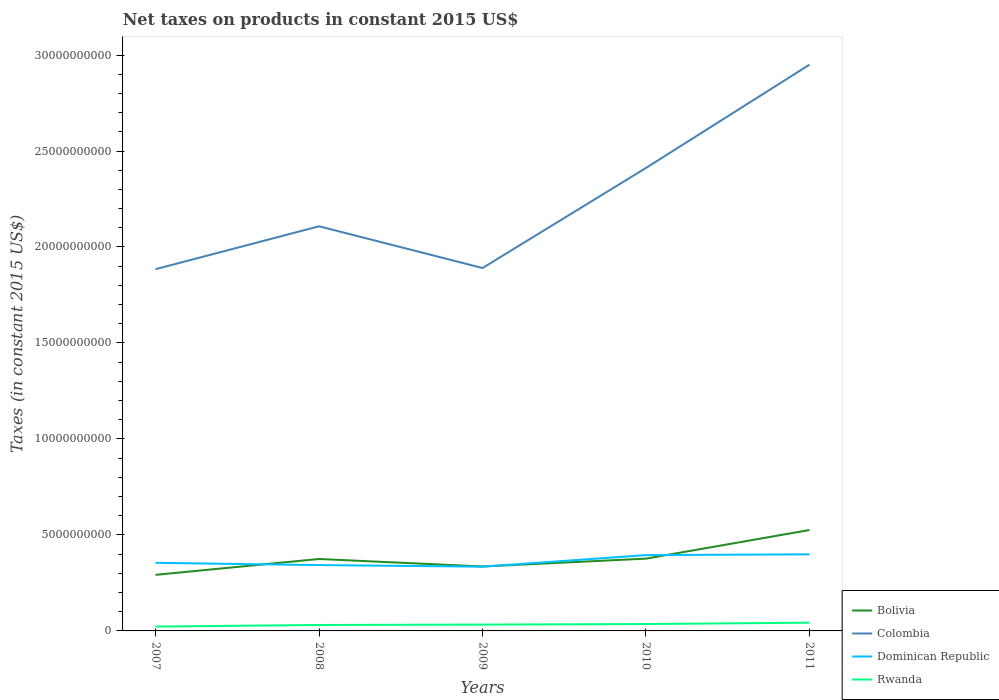How many different coloured lines are there?
Your answer should be compact. 4. Does the line corresponding to Rwanda intersect with the line corresponding to Colombia?
Offer a very short reply. No. Is the number of lines equal to the number of legend labels?
Give a very brief answer. Yes. Across all years, what is the maximum net taxes on products in Rwanda?
Offer a very short reply. 2.27e+08. In which year was the net taxes on products in Rwanda maximum?
Offer a terse response. 2007. What is the total net taxes on products in Dominican Republic in the graph?
Keep it short and to the point. -4.04e+07. What is the difference between the highest and the second highest net taxes on products in Dominican Republic?
Provide a short and direct response. 6.42e+08. How many lines are there?
Make the answer very short. 4. Does the graph contain any zero values?
Keep it short and to the point. No. Does the graph contain grids?
Give a very brief answer. No. How are the legend labels stacked?
Your response must be concise. Vertical. What is the title of the graph?
Your response must be concise. Net taxes on products in constant 2015 US$. What is the label or title of the X-axis?
Your answer should be very brief. Years. What is the label or title of the Y-axis?
Keep it short and to the point. Taxes (in constant 2015 US$). What is the Taxes (in constant 2015 US$) of Bolivia in 2007?
Ensure brevity in your answer.  2.92e+09. What is the Taxes (in constant 2015 US$) in Colombia in 2007?
Your answer should be compact. 1.88e+1. What is the Taxes (in constant 2015 US$) of Dominican Republic in 2007?
Your answer should be compact. 3.55e+09. What is the Taxes (in constant 2015 US$) of Rwanda in 2007?
Your response must be concise. 2.27e+08. What is the Taxes (in constant 2015 US$) of Bolivia in 2008?
Offer a terse response. 3.75e+09. What is the Taxes (in constant 2015 US$) in Colombia in 2008?
Offer a very short reply. 2.11e+1. What is the Taxes (in constant 2015 US$) of Dominican Republic in 2008?
Your response must be concise. 3.43e+09. What is the Taxes (in constant 2015 US$) in Rwanda in 2008?
Your answer should be very brief. 3.09e+08. What is the Taxes (in constant 2015 US$) of Bolivia in 2009?
Your answer should be compact. 3.36e+09. What is the Taxes (in constant 2015 US$) of Colombia in 2009?
Offer a very short reply. 1.89e+1. What is the Taxes (in constant 2015 US$) in Dominican Republic in 2009?
Your answer should be compact. 3.35e+09. What is the Taxes (in constant 2015 US$) of Rwanda in 2009?
Offer a terse response. 3.31e+08. What is the Taxes (in constant 2015 US$) in Bolivia in 2010?
Your answer should be compact. 3.77e+09. What is the Taxes (in constant 2015 US$) in Colombia in 2010?
Offer a terse response. 2.41e+1. What is the Taxes (in constant 2015 US$) of Dominican Republic in 2010?
Offer a terse response. 3.95e+09. What is the Taxes (in constant 2015 US$) of Rwanda in 2010?
Your answer should be very brief. 3.58e+08. What is the Taxes (in constant 2015 US$) of Bolivia in 2011?
Provide a short and direct response. 5.26e+09. What is the Taxes (in constant 2015 US$) of Colombia in 2011?
Offer a very short reply. 2.95e+1. What is the Taxes (in constant 2015 US$) of Dominican Republic in 2011?
Make the answer very short. 3.99e+09. What is the Taxes (in constant 2015 US$) of Rwanda in 2011?
Give a very brief answer. 4.30e+08. Across all years, what is the maximum Taxes (in constant 2015 US$) in Bolivia?
Offer a terse response. 5.26e+09. Across all years, what is the maximum Taxes (in constant 2015 US$) of Colombia?
Make the answer very short. 2.95e+1. Across all years, what is the maximum Taxes (in constant 2015 US$) of Dominican Republic?
Keep it short and to the point. 3.99e+09. Across all years, what is the maximum Taxes (in constant 2015 US$) in Rwanda?
Provide a short and direct response. 4.30e+08. Across all years, what is the minimum Taxes (in constant 2015 US$) of Bolivia?
Your answer should be compact. 2.92e+09. Across all years, what is the minimum Taxes (in constant 2015 US$) of Colombia?
Your answer should be compact. 1.88e+1. Across all years, what is the minimum Taxes (in constant 2015 US$) of Dominican Republic?
Offer a very short reply. 3.35e+09. Across all years, what is the minimum Taxes (in constant 2015 US$) in Rwanda?
Offer a terse response. 2.27e+08. What is the total Taxes (in constant 2015 US$) in Bolivia in the graph?
Ensure brevity in your answer.  1.90e+1. What is the total Taxes (in constant 2015 US$) of Colombia in the graph?
Make the answer very short. 1.12e+11. What is the total Taxes (in constant 2015 US$) of Dominican Republic in the graph?
Your response must be concise. 1.83e+1. What is the total Taxes (in constant 2015 US$) of Rwanda in the graph?
Ensure brevity in your answer.  1.65e+09. What is the difference between the Taxes (in constant 2015 US$) of Bolivia in 2007 and that in 2008?
Ensure brevity in your answer.  -8.27e+08. What is the difference between the Taxes (in constant 2015 US$) in Colombia in 2007 and that in 2008?
Give a very brief answer. -2.23e+09. What is the difference between the Taxes (in constant 2015 US$) of Dominican Republic in 2007 and that in 2008?
Offer a terse response. 1.17e+08. What is the difference between the Taxes (in constant 2015 US$) of Rwanda in 2007 and that in 2008?
Offer a terse response. -8.23e+07. What is the difference between the Taxes (in constant 2015 US$) of Bolivia in 2007 and that in 2009?
Keep it short and to the point. -4.36e+08. What is the difference between the Taxes (in constant 2015 US$) in Colombia in 2007 and that in 2009?
Provide a succinct answer. -6.03e+07. What is the difference between the Taxes (in constant 2015 US$) of Dominican Republic in 2007 and that in 2009?
Make the answer very short. 1.99e+08. What is the difference between the Taxes (in constant 2015 US$) in Rwanda in 2007 and that in 2009?
Offer a very short reply. -1.04e+08. What is the difference between the Taxes (in constant 2015 US$) of Bolivia in 2007 and that in 2010?
Your answer should be very brief. -8.45e+08. What is the difference between the Taxes (in constant 2015 US$) of Colombia in 2007 and that in 2010?
Provide a succinct answer. -5.27e+09. What is the difference between the Taxes (in constant 2015 US$) of Dominican Republic in 2007 and that in 2010?
Make the answer very short. -4.02e+08. What is the difference between the Taxes (in constant 2015 US$) in Rwanda in 2007 and that in 2010?
Offer a very short reply. -1.32e+08. What is the difference between the Taxes (in constant 2015 US$) in Bolivia in 2007 and that in 2011?
Your answer should be compact. -2.34e+09. What is the difference between the Taxes (in constant 2015 US$) of Colombia in 2007 and that in 2011?
Offer a very short reply. -1.07e+1. What is the difference between the Taxes (in constant 2015 US$) in Dominican Republic in 2007 and that in 2011?
Make the answer very short. -4.43e+08. What is the difference between the Taxes (in constant 2015 US$) in Rwanda in 2007 and that in 2011?
Offer a terse response. -2.03e+08. What is the difference between the Taxes (in constant 2015 US$) in Bolivia in 2008 and that in 2009?
Your answer should be very brief. 3.91e+08. What is the difference between the Taxes (in constant 2015 US$) of Colombia in 2008 and that in 2009?
Provide a short and direct response. 2.17e+09. What is the difference between the Taxes (in constant 2015 US$) of Dominican Republic in 2008 and that in 2009?
Ensure brevity in your answer.  8.22e+07. What is the difference between the Taxes (in constant 2015 US$) of Rwanda in 2008 and that in 2009?
Ensure brevity in your answer.  -2.18e+07. What is the difference between the Taxes (in constant 2015 US$) of Bolivia in 2008 and that in 2010?
Offer a terse response. -1.85e+07. What is the difference between the Taxes (in constant 2015 US$) of Colombia in 2008 and that in 2010?
Keep it short and to the point. -3.04e+09. What is the difference between the Taxes (in constant 2015 US$) of Dominican Republic in 2008 and that in 2010?
Your answer should be compact. -5.19e+08. What is the difference between the Taxes (in constant 2015 US$) in Rwanda in 2008 and that in 2010?
Your answer should be compact. -4.94e+07. What is the difference between the Taxes (in constant 2015 US$) of Bolivia in 2008 and that in 2011?
Your response must be concise. -1.51e+09. What is the difference between the Taxes (in constant 2015 US$) of Colombia in 2008 and that in 2011?
Provide a short and direct response. -8.42e+09. What is the difference between the Taxes (in constant 2015 US$) in Dominican Republic in 2008 and that in 2011?
Provide a succinct answer. -5.60e+08. What is the difference between the Taxes (in constant 2015 US$) of Rwanda in 2008 and that in 2011?
Your response must be concise. -1.21e+08. What is the difference between the Taxes (in constant 2015 US$) of Bolivia in 2009 and that in 2010?
Ensure brevity in your answer.  -4.09e+08. What is the difference between the Taxes (in constant 2015 US$) in Colombia in 2009 and that in 2010?
Provide a succinct answer. -5.21e+09. What is the difference between the Taxes (in constant 2015 US$) of Dominican Republic in 2009 and that in 2010?
Make the answer very short. -6.01e+08. What is the difference between the Taxes (in constant 2015 US$) of Rwanda in 2009 and that in 2010?
Offer a terse response. -2.76e+07. What is the difference between the Taxes (in constant 2015 US$) in Bolivia in 2009 and that in 2011?
Your answer should be very brief. -1.90e+09. What is the difference between the Taxes (in constant 2015 US$) in Colombia in 2009 and that in 2011?
Offer a very short reply. -1.06e+1. What is the difference between the Taxes (in constant 2015 US$) of Dominican Republic in 2009 and that in 2011?
Offer a very short reply. -6.42e+08. What is the difference between the Taxes (in constant 2015 US$) of Rwanda in 2009 and that in 2011?
Keep it short and to the point. -9.90e+07. What is the difference between the Taxes (in constant 2015 US$) in Bolivia in 2010 and that in 2011?
Make the answer very short. -1.49e+09. What is the difference between the Taxes (in constant 2015 US$) in Colombia in 2010 and that in 2011?
Your answer should be very brief. -5.38e+09. What is the difference between the Taxes (in constant 2015 US$) of Dominican Republic in 2010 and that in 2011?
Your answer should be very brief. -4.04e+07. What is the difference between the Taxes (in constant 2015 US$) in Rwanda in 2010 and that in 2011?
Offer a very short reply. -7.14e+07. What is the difference between the Taxes (in constant 2015 US$) in Bolivia in 2007 and the Taxes (in constant 2015 US$) in Colombia in 2008?
Your response must be concise. -1.82e+1. What is the difference between the Taxes (in constant 2015 US$) of Bolivia in 2007 and the Taxes (in constant 2015 US$) of Dominican Republic in 2008?
Provide a succinct answer. -5.10e+08. What is the difference between the Taxes (in constant 2015 US$) of Bolivia in 2007 and the Taxes (in constant 2015 US$) of Rwanda in 2008?
Provide a succinct answer. 2.61e+09. What is the difference between the Taxes (in constant 2015 US$) of Colombia in 2007 and the Taxes (in constant 2015 US$) of Dominican Republic in 2008?
Keep it short and to the point. 1.54e+1. What is the difference between the Taxes (in constant 2015 US$) of Colombia in 2007 and the Taxes (in constant 2015 US$) of Rwanda in 2008?
Your response must be concise. 1.85e+1. What is the difference between the Taxes (in constant 2015 US$) of Dominican Republic in 2007 and the Taxes (in constant 2015 US$) of Rwanda in 2008?
Keep it short and to the point. 3.24e+09. What is the difference between the Taxes (in constant 2015 US$) of Bolivia in 2007 and the Taxes (in constant 2015 US$) of Colombia in 2009?
Give a very brief answer. -1.60e+1. What is the difference between the Taxes (in constant 2015 US$) of Bolivia in 2007 and the Taxes (in constant 2015 US$) of Dominican Republic in 2009?
Your answer should be very brief. -4.28e+08. What is the difference between the Taxes (in constant 2015 US$) in Bolivia in 2007 and the Taxes (in constant 2015 US$) in Rwanda in 2009?
Provide a short and direct response. 2.59e+09. What is the difference between the Taxes (in constant 2015 US$) of Colombia in 2007 and the Taxes (in constant 2015 US$) of Dominican Republic in 2009?
Your answer should be very brief. 1.55e+1. What is the difference between the Taxes (in constant 2015 US$) of Colombia in 2007 and the Taxes (in constant 2015 US$) of Rwanda in 2009?
Offer a very short reply. 1.85e+1. What is the difference between the Taxes (in constant 2015 US$) in Dominican Republic in 2007 and the Taxes (in constant 2015 US$) in Rwanda in 2009?
Give a very brief answer. 3.22e+09. What is the difference between the Taxes (in constant 2015 US$) in Bolivia in 2007 and the Taxes (in constant 2015 US$) in Colombia in 2010?
Ensure brevity in your answer.  -2.12e+1. What is the difference between the Taxes (in constant 2015 US$) of Bolivia in 2007 and the Taxes (in constant 2015 US$) of Dominican Republic in 2010?
Your answer should be very brief. -1.03e+09. What is the difference between the Taxes (in constant 2015 US$) of Bolivia in 2007 and the Taxes (in constant 2015 US$) of Rwanda in 2010?
Your response must be concise. 2.56e+09. What is the difference between the Taxes (in constant 2015 US$) of Colombia in 2007 and the Taxes (in constant 2015 US$) of Dominican Republic in 2010?
Give a very brief answer. 1.49e+1. What is the difference between the Taxes (in constant 2015 US$) in Colombia in 2007 and the Taxes (in constant 2015 US$) in Rwanda in 2010?
Keep it short and to the point. 1.85e+1. What is the difference between the Taxes (in constant 2015 US$) in Dominican Republic in 2007 and the Taxes (in constant 2015 US$) in Rwanda in 2010?
Provide a short and direct response. 3.19e+09. What is the difference between the Taxes (in constant 2015 US$) of Bolivia in 2007 and the Taxes (in constant 2015 US$) of Colombia in 2011?
Keep it short and to the point. -2.66e+1. What is the difference between the Taxes (in constant 2015 US$) in Bolivia in 2007 and the Taxes (in constant 2015 US$) in Dominican Republic in 2011?
Keep it short and to the point. -1.07e+09. What is the difference between the Taxes (in constant 2015 US$) in Bolivia in 2007 and the Taxes (in constant 2015 US$) in Rwanda in 2011?
Provide a short and direct response. 2.49e+09. What is the difference between the Taxes (in constant 2015 US$) in Colombia in 2007 and the Taxes (in constant 2015 US$) in Dominican Republic in 2011?
Keep it short and to the point. 1.49e+1. What is the difference between the Taxes (in constant 2015 US$) in Colombia in 2007 and the Taxes (in constant 2015 US$) in Rwanda in 2011?
Keep it short and to the point. 1.84e+1. What is the difference between the Taxes (in constant 2015 US$) in Dominican Republic in 2007 and the Taxes (in constant 2015 US$) in Rwanda in 2011?
Provide a succinct answer. 3.12e+09. What is the difference between the Taxes (in constant 2015 US$) of Bolivia in 2008 and the Taxes (in constant 2015 US$) of Colombia in 2009?
Your answer should be very brief. -1.52e+1. What is the difference between the Taxes (in constant 2015 US$) in Bolivia in 2008 and the Taxes (in constant 2015 US$) in Dominican Republic in 2009?
Provide a succinct answer. 3.99e+08. What is the difference between the Taxes (in constant 2015 US$) of Bolivia in 2008 and the Taxes (in constant 2015 US$) of Rwanda in 2009?
Your answer should be very brief. 3.42e+09. What is the difference between the Taxes (in constant 2015 US$) in Colombia in 2008 and the Taxes (in constant 2015 US$) in Dominican Republic in 2009?
Offer a terse response. 1.77e+1. What is the difference between the Taxes (in constant 2015 US$) in Colombia in 2008 and the Taxes (in constant 2015 US$) in Rwanda in 2009?
Provide a short and direct response. 2.07e+1. What is the difference between the Taxes (in constant 2015 US$) of Dominican Republic in 2008 and the Taxes (in constant 2015 US$) of Rwanda in 2009?
Offer a very short reply. 3.10e+09. What is the difference between the Taxes (in constant 2015 US$) of Bolivia in 2008 and the Taxes (in constant 2015 US$) of Colombia in 2010?
Provide a succinct answer. -2.04e+1. What is the difference between the Taxes (in constant 2015 US$) in Bolivia in 2008 and the Taxes (in constant 2015 US$) in Dominican Republic in 2010?
Provide a succinct answer. -2.02e+08. What is the difference between the Taxes (in constant 2015 US$) in Bolivia in 2008 and the Taxes (in constant 2015 US$) in Rwanda in 2010?
Offer a very short reply. 3.39e+09. What is the difference between the Taxes (in constant 2015 US$) in Colombia in 2008 and the Taxes (in constant 2015 US$) in Dominican Republic in 2010?
Provide a short and direct response. 1.71e+1. What is the difference between the Taxes (in constant 2015 US$) of Colombia in 2008 and the Taxes (in constant 2015 US$) of Rwanda in 2010?
Your answer should be very brief. 2.07e+1. What is the difference between the Taxes (in constant 2015 US$) in Dominican Republic in 2008 and the Taxes (in constant 2015 US$) in Rwanda in 2010?
Offer a very short reply. 3.07e+09. What is the difference between the Taxes (in constant 2015 US$) in Bolivia in 2008 and the Taxes (in constant 2015 US$) in Colombia in 2011?
Your answer should be very brief. -2.57e+1. What is the difference between the Taxes (in constant 2015 US$) of Bolivia in 2008 and the Taxes (in constant 2015 US$) of Dominican Republic in 2011?
Your answer should be very brief. -2.42e+08. What is the difference between the Taxes (in constant 2015 US$) of Bolivia in 2008 and the Taxes (in constant 2015 US$) of Rwanda in 2011?
Offer a very short reply. 3.32e+09. What is the difference between the Taxes (in constant 2015 US$) in Colombia in 2008 and the Taxes (in constant 2015 US$) in Dominican Republic in 2011?
Offer a very short reply. 1.71e+1. What is the difference between the Taxes (in constant 2015 US$) of Colombia in 2008 and the Taxes (in constant 2015 US$) of Rwanda in 2011?
Make the answer very short. 2.06e+1. What is the difference between the Taxes (in constant 2015 US$) of Dominican Republic in 2008 and the Taxes (in constant 2015 US$) of Rwanda in 2011?
Your answer should be very brief. 3.00e+09. What is the difference between the Taxes (in constant 2015 US$) in Bolivia in 2009 and the Taxes (in constant 2015 US$) in Colombia in 2010?
Offer a very short reply. -2.08e+1. What is the difference between the Taxes (in constant 2015 US$) of Bolivia in 2009 and the Taxes (in constant 2015 US$) of Dominican Republic in 2010?
Keep it short and to the point. -5.93e+08. What is the difference between the Taxes (in constant 2015 US$) in Bolivia in 2009 and the Taxes (in constant 2015 US$) in Rwanda in 2010?
Your answer should be compact. 3.00e+09. What is the difference between the Taxes (in constant 2015 US$) in Colombia in 2009 and the Taxes (in constant 2015 US$) in Dominican Republic in 2010?
Make the answer very short. 1.50e+1. What is the difference between the Taxes (in constant 2015 US$) in Colombia in 2009 and the Taxes (in constant 2015 US$) in Rwanda in 2010?
Provide a short and direct response. 1.85e+1. What is the difference between the Taxes (in constant 2015 US$) in Dominican Republic in 2009 and the Taxes (in constant 2015 US$) in Rwanda in 2010?
Keep it short and to the point. 2.99e+09. What is the difference between the Taxes (in constant 2015 US$) of Bolivia in 2009 and the Taxes (in constant 2015 US$) of Colombia in 2011?
Ensure brevity in your answer.  -2.61e+1. What is the difference between the Taxes (in constant 2015 US$) in Bolivia in 2009 and the Taxes (in constant 2015 US$) in Dominican Republic in 2011?
Your response must be concise. -6.33e+08. What is the difference between the Taxes (in constant 2015 US$) of Bolivia in 2009 and the Taxes (in constant 2015 US$) of Rwanda in 2011?
Keep it short and to the point. 2.93e+09. What is the difference between the Taxes (in constant 2015 US$) of Colombia in 2009 and the Taxes (in constant 2015 US$) of Dominican Republic in 2011?
Your answer should be very brief. 1.49e+1. What is the difference between the Taxes (in constant 2015 US$) of Colombia in 2009 and the Taxes (in constant 2015 US$) of Rwanda in 2011?
Provide a short and direct response. 1.85e+1. What is the difference between the Taxes (in constant 2015 US$) of Dominican Republic in 2009 and the Taxes (in constant 2015 US$) of Rwanda in 2011?
Your answer should be compact. 2.92e+09. What is the difference between the Taxes (in constant 2015 US$) of Bolivia in 2010 and the Taxes (in constant 2015 US$) of Colombia in 2011?
Your answer should be compact. -2.57e+1. What is the difference between the Taxes (in constant 2015 US$) in Bolivia in 2010 and the Taxes (in constant 2015 US$) in Dominican Republic in 2011?
Give a very brief answer. -2.24e+08. What is the difference between the Taxes (in constant 2015 US$) of Bolivia in 2010 and the Taxes (in constant 2015 US$) of Rwanda in 2011?
Keep it short and to the point. 3.34e+09. What is the difference between the Taxes (in constant 2015 US$) of Colombia in 2010 and the Taxes (in constant 2015 US$) of Dominican Republic in 2011?
Offer a very short reply. 2.01e+1. What is the difference between the Taxes (in constant 2015 US$) of Colombia in 2010 and the Taxes (in constant 2015 US$) of Rwanda in 2011?
Your response must be concise. 2.37e+1. What is the difference between the Taxes (in constant 2015 US$) in Dominican Republic in 2010 and the Taxes (in constant 2015 US$) in Rwanda in 2011?
Keep it short and to the point. 3.52e+09. What is the average Taxes (in constant 2015 US$) of Bolivia per year?
Your answer should be very brief. 3.81e+09. What is the average Taxes (in constant 2015 US$) in Colombia per year?
Offer a very short reply. 2.25e+1. What is the average Taxes (in constant 2015 US$) in Dominican Republic per year?
Your answer should be very brief. 3.65e+09. What is the average Taxes (in constant 2015 US$) of Rwanda per year?
Keep it short and to the point. 3.31e+08. In the year 2007, what is the difference between the Taxes (in constant 2015 US$) in Bolivia and Taxes (in constant 2015 US$) in Colombia?
Give a very brief answer. -1.59e+1. In the year 2007, what is the difference between the Taxes (in constant 2015 US$) of Bolivia and Taxes (in constant 2015 US$) of Dominican Republic?
Provide a succinct answer. -6.27e+08. In the year 2007, what is the difference between the Taxes (in constant 2015 US$) in Bolivia and Taxes (in constant 2015 US$) in Rwanda?
Provide a short and direct response. 2.69e+09. In the year 2007, what is the difference between the Taxes (in constant 2015 US$) of Colombia and Taxes (in constant 2015 US$) of Dominican Republic?
Your response must be concise. 1.53e+1. In the year 2007, what is the difference between the Taxes (in constant 2015 US$) in Colombia and Taxes (in constant 2015 US$) in Rwanda?
Your answer should be compact. 1.86e+1. In the year 2007, what is the difference between the Taxes (in constant 2015 US$) of Dominican Republic and Taxes (in constant 2015 US$) of Rwanda?
Offer a terse response. 3.32e+09. In the year 2008, what is the difference between the Taxes (in constant 2015 US$) in Bolivia and Taxes (in constant 2015 US$) in Colombia?
Provide a short and direct response. -1.73e+1. In the year 2008, what is the difference between the Taxes (in constant 2015 US$) of Bolivia and Taxes (in constant 2015 US$) of Dominican Republic?
Keep it short and to the point. 3.17e+08. In the year 2008, what is the difference between the Taxes (in constant 2015 US$) in Bolivia and Taxes (in constant 2015 US$) in Rwanda?
Offer a very short reply. 3.44e+09. In the year 2008, what is the difference between the Taxes (in constant 2015 US$) of Colombia and Taxes (in constant 2015 US$) of Dominican Republic?
Your answer should be very brief. 1.76e+1. In the year 2008, what is the difference between the Taxes (in constant 2015 US$) in Colombia and Taxes (in constant 2015 US$) in Rwanda?
Your answer should be compact. 2.08e+1. In the year 2008, what is the difference between the Taxes (in constant 2015 US$) in Dominican Republic and Taxes (in constant 2015 US$) in Rwanda?
Provide a succinct answer. 3.12e+09. In the year 2009, what is the difference between the Taxes (in constant 2015 US$) in Bolivia and Taxes (in constant 2015 US$) in Colombia?
Offer a terse response. -1.55e+1. In the year 2009, what is the difference between the Taxes (in constant 2015 US$) of Bolivia and Taxes (in constant 2015 US$) of Dominican Republic?
Your response must be concise. 8.67e+06. In the year 2009, what is the difference between the Taxes (in constant 2015 US$) of Bolivia and Taxes (in constant 2015 US$) of Rwanda?
Your response must be concise. 3.03e+09. In the year 2009, what is the difference between the Taxes (in constant 2015 US$) in Colombia and Taxes (in constant 2015 US$) in Dominican Republic?
Give a very brief answer. 1.56e+1. In the year 2009, what is the difference between the Taxes (in constant 2015 US$) in Colombia and Taxes (in constant 2015 US$) in Rwanda?
Provide a short and direct response. 1.86e+1. In the year 2009, what is the difference between the Taxes (in constant 2015 US$) of Dominican Republic and Taxes (in constant 2015 US$) of Rwanda?
Keep it short and to the point. 3.02e+09. In the year 2010, what is the difference between the Taxes (in constant 2015 US$) in Bolivia and Taxes (in constant 2015 US$) in Colombia?
Offer a very short reply. -2.04e+1. In the year 2010, what is the difference between the Taxes (in constant 2015 US$) of Bolivia and Taxes (in constant 2015 US$) of Dominican Republic?
Your response must be concise. -1.83e+08. In the year 2010, what is the difference between the Taxes (in constant 2015 US$) of Bolivia and Taxes (in constant 2015 US$) of Rwanda?
Offer a terse response. 3.41e+09. In the year 2010, what is the difference between the Taxes (in constant 2015 US$) of Colombia and Taxes (in constant 2015 US$) of Dominican Republic?
Keep it short and to the point. 2.02e+1. In the year 2010, what is the difference between the Taxes (in constant 2015 US$) in Colombia and Taxes (in constant 2015 US$) in Rwanda?
Your response must be concise. 2.38e+1. In the year 2010, what is the difference between the Taxes (in constant 2015 US$) of Dominican Republic and Taxes (in constant 2015 US$) of Rwanda?
Provide a short and direct response. 3.59e+09. In the year 2011, what is the difference between the Taxes (in constant 2015 US$) of Bolivia and Taxes (in constant 2015 US$) of Colombia?
Give a very brief answer. -2.42e+1. In the year 2011, what is the difference between the Taxes (in constant 2015 US$) of Bolivia and Taxes (in constant 2015 US$) of Dominican Republic?
Ensure brevity in your answer.  1.27e+09. In the year 2011, what is the difference between the Taxes (in constant 2015 US$) of Bolivia and Taxes (in constant 2015 US$) of Rwanda?
Your answer should be compact. 4.83e+09. In the year 2011, what is the difference between the Taxes (in constant 2015 US$) in Colombia and Taxes (in constant 2015 US$) in Dominican Republic?
Provide a succinct answer. 2.55e+1. In the year 2011, what is the difference between the Taxes (in constant 2015 US$) of Colombia and Taxes (in constant 2015 US$) of Rwanda?
Offer a very short reply. 2.91e+1. In the year 2011, what is the difference between the Taxes (in constant 2015 US$) in Dominican Republic and Taxes (in constant 2015 US$) in Rwanda?
Provide a succinct answer. 3.56e+09. What is the ratio of the Taxes (in constant 2015 US$) in Bolivia in 2007 to that in 2008?
Provide a short and direct response. 0.78. What is the ratio of the Taxes (in constant 2015 US$) in Colombia in 2007 to that in 2008?
Ensure brevity in your answer.  0.89. What is the ratio of the Taxes (in constant 2015 US$) in Dominican Republic in 2007 to that in 2008?
Your response must be concise. 1.03. What is the ratio of the Taxes (in constant 2015 US$) in Rwanda in 2007 to that in 2008?
Make the answer very short. 0.73. What is the ratio of the Taxes (in constant 2015 US$) in Bolivia in 2007 to that in 2009?
Offer a very short reply. 0.87. What is the ratio of the Taxes (in constant 2015 US$) in Dominican Republic in 2007 to that in 2009?
Provide a short and direct response. 1.06. What is the ratio of the Taxes (in constant 2015 US$) of Rwanda in 2007 to that in 2009?
Provide a succinct answer. 0.69. What is the ratio of the Taxes (in constant 2015 US$) of Bolivia in 2007 to that in 2010?
Ensure brevity in your answer.  0.78. What is the ratio of the Taxes (in constant 2015 US$) of Colombia in 2007 to that in 2010?
Give a very brief answer. 0.78. What is the ratio of the Taxes (in constant 2015 US$) in Dominican Republic in 2007 to that in 2010?
Make the answer very short. 0.9. What is the ratio of the Taxes (in constant 2015 US$) of Rwanda in 2007 to that in 2010?
Provide a succinct answer. 0.63. What is the ratio of the Taxes (in constant 2015 US$) of Bolivia in 2007 to that in 2011?
Make the answer very short. 0.56. What is the ratio of the Taxes (in constant 2015 US$) in Colombia in 2007 to that in 2011?
Your answer should be very brief. 0.64. What is the ratio of the Taxes (in constant 2015 US$) in Dominican Republic in 2007 to that in 2011?
Provide a succinct answer. 0.89. What is the ratio of the Taxes (in constant 2015 US$) of Rwanda in 2007 to that in 2011?
Give a very brief answer. 0.53. What is the ratio of the Taxes (in constant 2015 US$) of Bolivia in 2008 to that in 2009?
Your answer should be very brief. 1.12. What is the ratio of the Taxes (in constant 2015 US$) of Colombia in 2008 to that in 2009?
Offer a terse response. 1.11. What is the ratio of the Taxes (in constant 2015 US$) of Dominican Republic in 2008 to that in 2009?
Keep it short and to the point. 1.02. What is the ratio of the Taxes (in constant 2015 US$) of Rwanda in 2008 to that in 2009?
Provide a short and direct response. 0.93. What is the ratio of the Taxes (in constant 2015 US$) in Colombia in 2008 to that in 2010?
Provide a short and direct response. 0.87. What is the ratio of the Taxes (in constant 2015 US$) of Dominican Republic in 2008 to that in 2010?
Provide a short and direct response. 0.87. What is the ratio of the Taxes (in constant 2015 US$) in Rwanda in 2008 to that in 2010?
Your answer should be very brief. 0.86. What is the ratio of the Taxes (in constant 2015 US$) of Bolivia in 2008 to that in 2011?
Provide a short and direct response. 0.71. What is the ratio of the Taxes (in constant 2015 US$) in Colombia in 2008 to that in 2011?
Give a very brief answer. 0.71. What is the ratio of the Taxes (in constant 2015 US$) in Dominican Republic in 2008 to that in 2011?
Provide a succinct answer. 0.86. What is the ratio of the Taxes (in constant 2015 US$) in Rwanda in 2008 to that in 2011?
Your answer should be very brief. 0.72. What is the ratio of the Taxes (in constant 2015 US$) of Bolivia in 2009 to that in 2010?
Give a very brief answer. 0.89. What is the ratio of the Taxes (in constant 2015 US$) of Colombia in 2009 to that in 2010?
Ensure brevity in your answer.  0.78. What is the ratio of the Taxes (in constant 2015 US$) in Dominican Republic in 2009 to that in 2010?
Keep it short and to the point. 0.85. What is the ratio of the Taxes (in constant 2015 US$) in Rwanda in 2009 to that in 2010?
Offer a very short reply. 0.92. What is the ratio of the Taxes (in constant 2015 US$) in Bolivia in 2009 to that in 2011?
Ensure brevity in your answer.  0.64. What is the ratio of the Taxes (in constant 2015 US$) in Colombia in 2009 to that in 2011?
Keep it short and to the point. 0.64. What is the ratio of the Taxes (in constant 2015 US$) of Dominican Republic in 2009 to that in 2011?
Offer a terse response. 0.84. What is the ratio of the Taxes (in constant 2015 US$) in Rwanda in 2009 to that in 2011?
Provide a succinct answer. 0.77. What is the ratio of the Taxes (in constant 2015 US$) in Bolivia in 2010 to that in 2011?
Provide a short and direct response. 0.72. What is the ratio of the Taxes (in constant 2015 US$) of Colombia in 2010 to that in 2011?
Offer a terse response. 0.82. What is the ratio of the Taxes (in constant 2015 US$) in Rwanda in 2010 to that in 2011?
Your response must be concise. 0.83. What is the difference between the highest and the second highest Taxes (in constant 2015 US$) of Bolivia?
Your answer should be very brief. 1.49e+09. What is the difference between the highest and the second highest Taxes (in constant 2015 US$) of Colombia?
Ensure brevity in your answer.  5.38e+09. What is the difference between the highest and the second highest Taxes (in constant 2015 US$) in Dominican Republic?
Make the answer very short. 4.04e+07. What is the difference between the highest and the second highest Taxes (in constant 2015 US$) of Rwanda?
Provide a short and direct response. 7.14e+07. What is the difference between the highest and the lowest Taxes (in constant 2015 US$) of Bolivia?
Ensure brevity in your answer.  2.34e+09. What is the difference between the highest and the lowest Taxes (in constant 2015 US$) in Colombia?
Make the answer very short. 1.07e+1. What is the difference between the highest and the lowest Taxes (in constant 2015 US$) of Dominican Republic?
Make the answer very short. 6.42e+08. What is the difference between the highest and the lowest Taxes (in constant 2015 US$) of Rwanda?
Offer a terse response. 2.03e+08. 